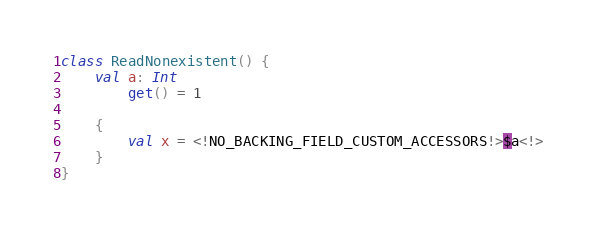<code> <loc_0><loc_0><loc_500><loc_500><_Kotlin_>class ReadNonexistent() {
    val a: Int
        get() = 1

    {
        val x = <!NO_BACKING_FIELD_CUSTOM_ACCESSORS!>$a<!>
    }
}
</code> 